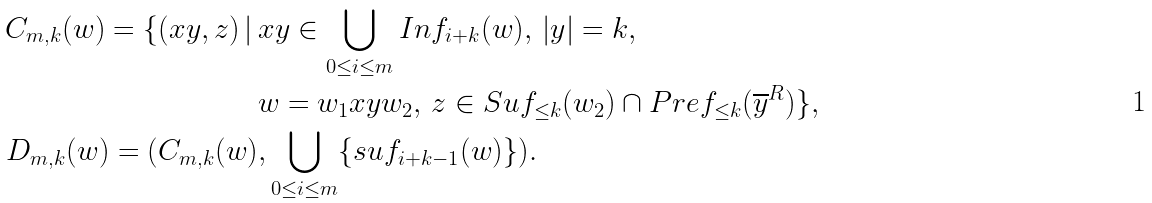<formula> <loc_0><loc_0><loc_500><loc_500>C _ { m , k } ( w ) = \{ ( x y , z ) \, | \, & x y \in \bigcup _ { 0 \leq i \leq m } I n f _ { i + k } ( w ) , \, | y | = k , \, \\ & w = w _ { 1 } x y w _ { 2 } , \, z \in S u f _ { \leq k } ( w _ { 2 } ) \cap P r e f _ { \leq k } ( { \overline { y } } ^ { R } ) \} , \\ D _ { m , k } ( w ) = ( C _ { m , k } ( w ) & , \bigcup _ { 0 \leq i \leq m } \{ s u f _ { i + k - 1 } ( w ) \} ) .</formula> 